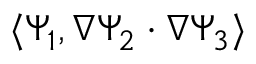<formula> <loc_0><loc_0><loc_500><loc_500>\langle \Psi _ { 1 } , \nabla \Psi _ { 2 } \cdot \nabla \Psi _ { 3 } \rangle</formula> 